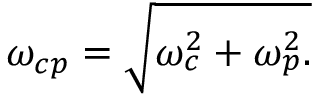Convert formula to latex. <formula><loc_0><loc_0><loc_500><loc_500>\omega _ { c p } = \sqrt { \omega _ { c } ^ { 2 } + \omega _ { p } ^ { 2 } . }</formula> 